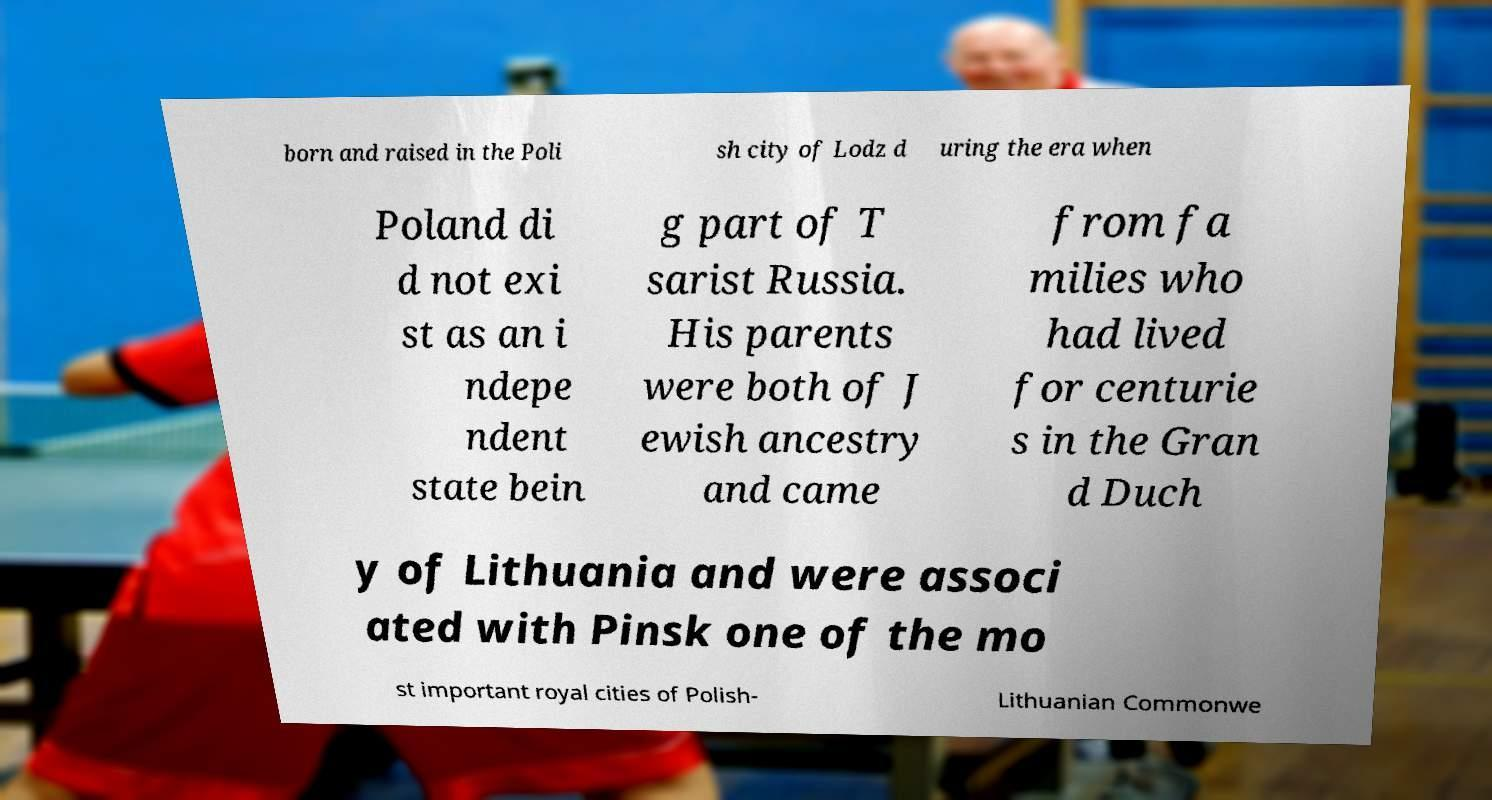Please read and relay the text visible in this image. What does it say? born and raised in the Poli sh city of Lodz d uring the era when Poland di d not exi st as an i ndepe ndent state bein g part of T sarist Russia. His parents were both of J ewish ancestry and came from fa milies who had lived for centurie s in the Gran d Duch y of Lithuania and were associ ated with Pinsk one of the mo st important royal cities of Polish- Lithuanian Commonwe 